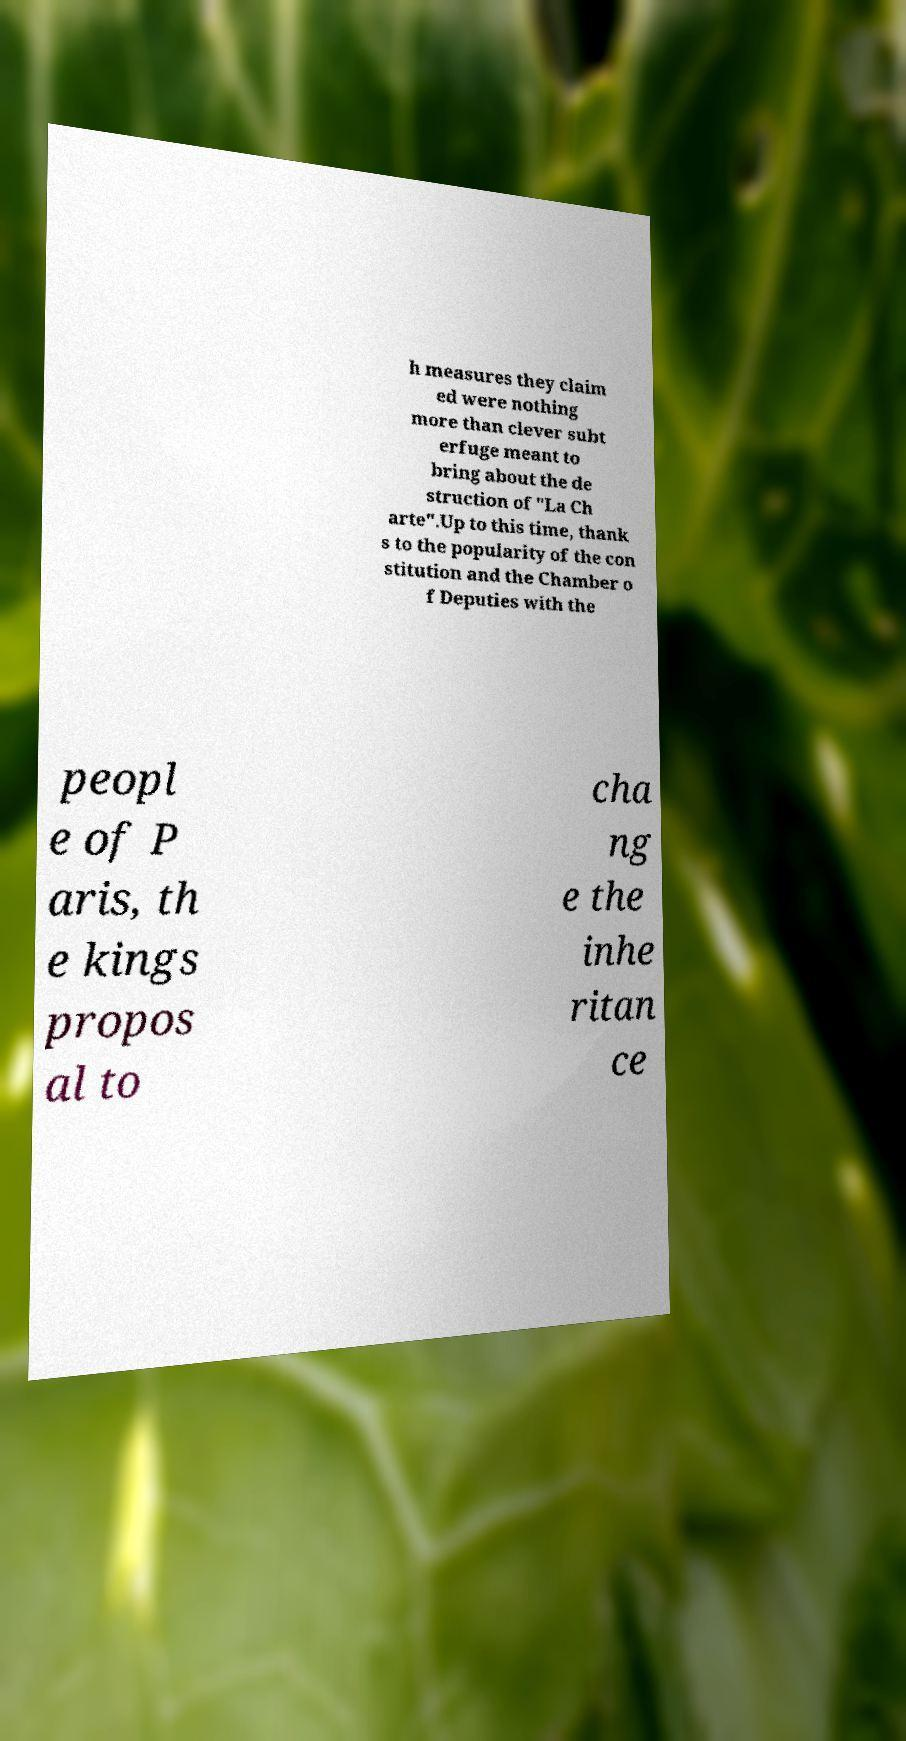Please identify and transcribe the text found in this image. h measures they claim ed were nothing more than clever subt erfuge meant to bring about the de struction of "La Ch arte".Up to this time, thank s to the popularity of the con stitution and the Chamber o f Deputies with the peopl e of P aris, th e kings propos al to cha ng e the inhe ritan ce 